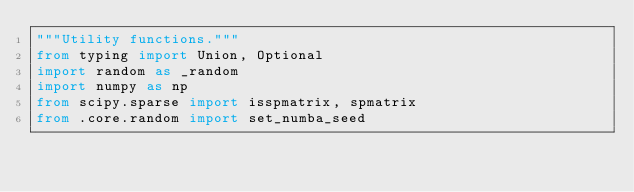<code> <loc_0><loc_0><loc_500><loc_500><_Python_>"""Utility functions."""
from typing import Union, Optional
import random as _random
import numpy as np
from scipy.sparse import isspmatrix, spmatrix
from .core.random import set_numba_seed</code> 